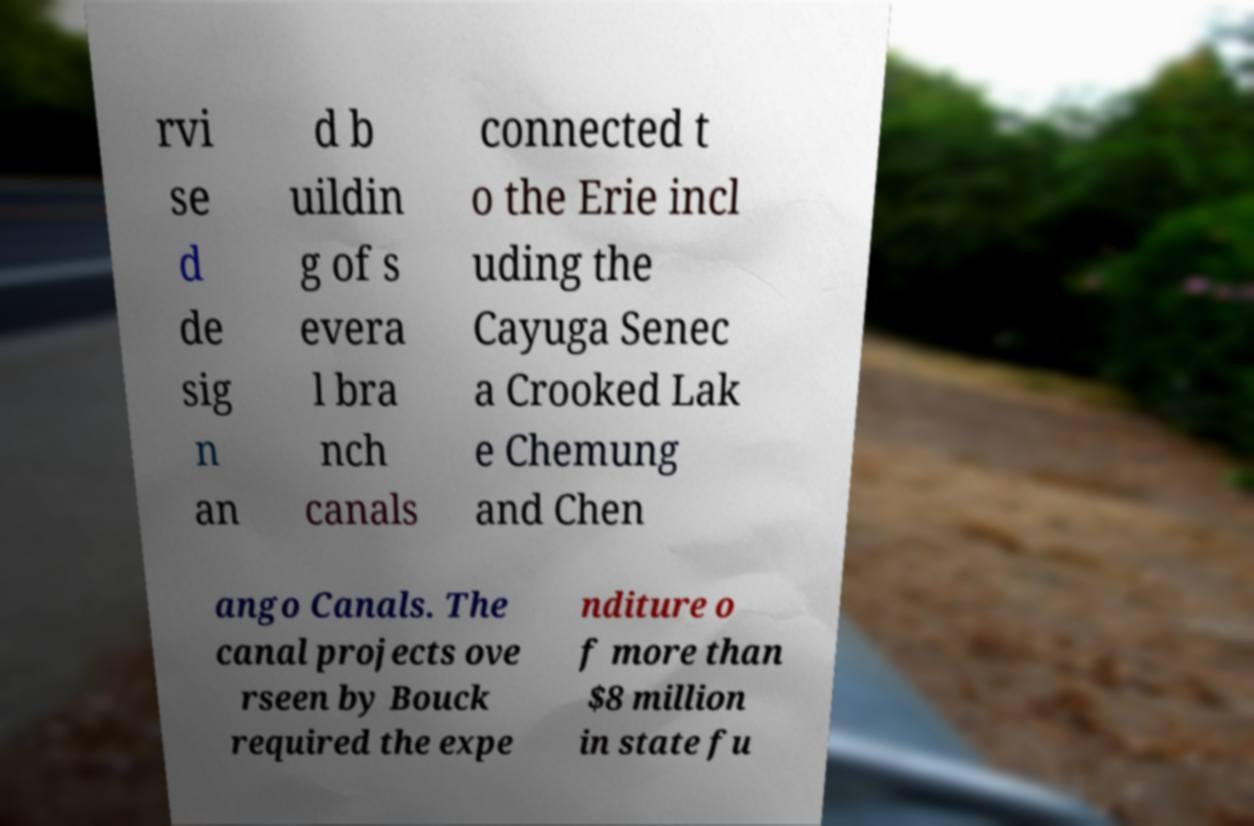Could you assist in decoding the text presented in this image and type it out clearly? rvi se d de sig n an d b uildin g of s evera l bra nch canals connected t o the Erie incl uding the Cayuga Senec a Crooked Lak e Chemung and Chen ango Canals. The canal projects ove rseen by Bouck required the expe nditure o f more than $8 million in state fu 